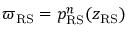<formula> <loc_0><loc_0><loc_500><loc_500>\varpi _ { R S } = p _ { R S } ^ { n } ( z _ { R S } )</formula> 